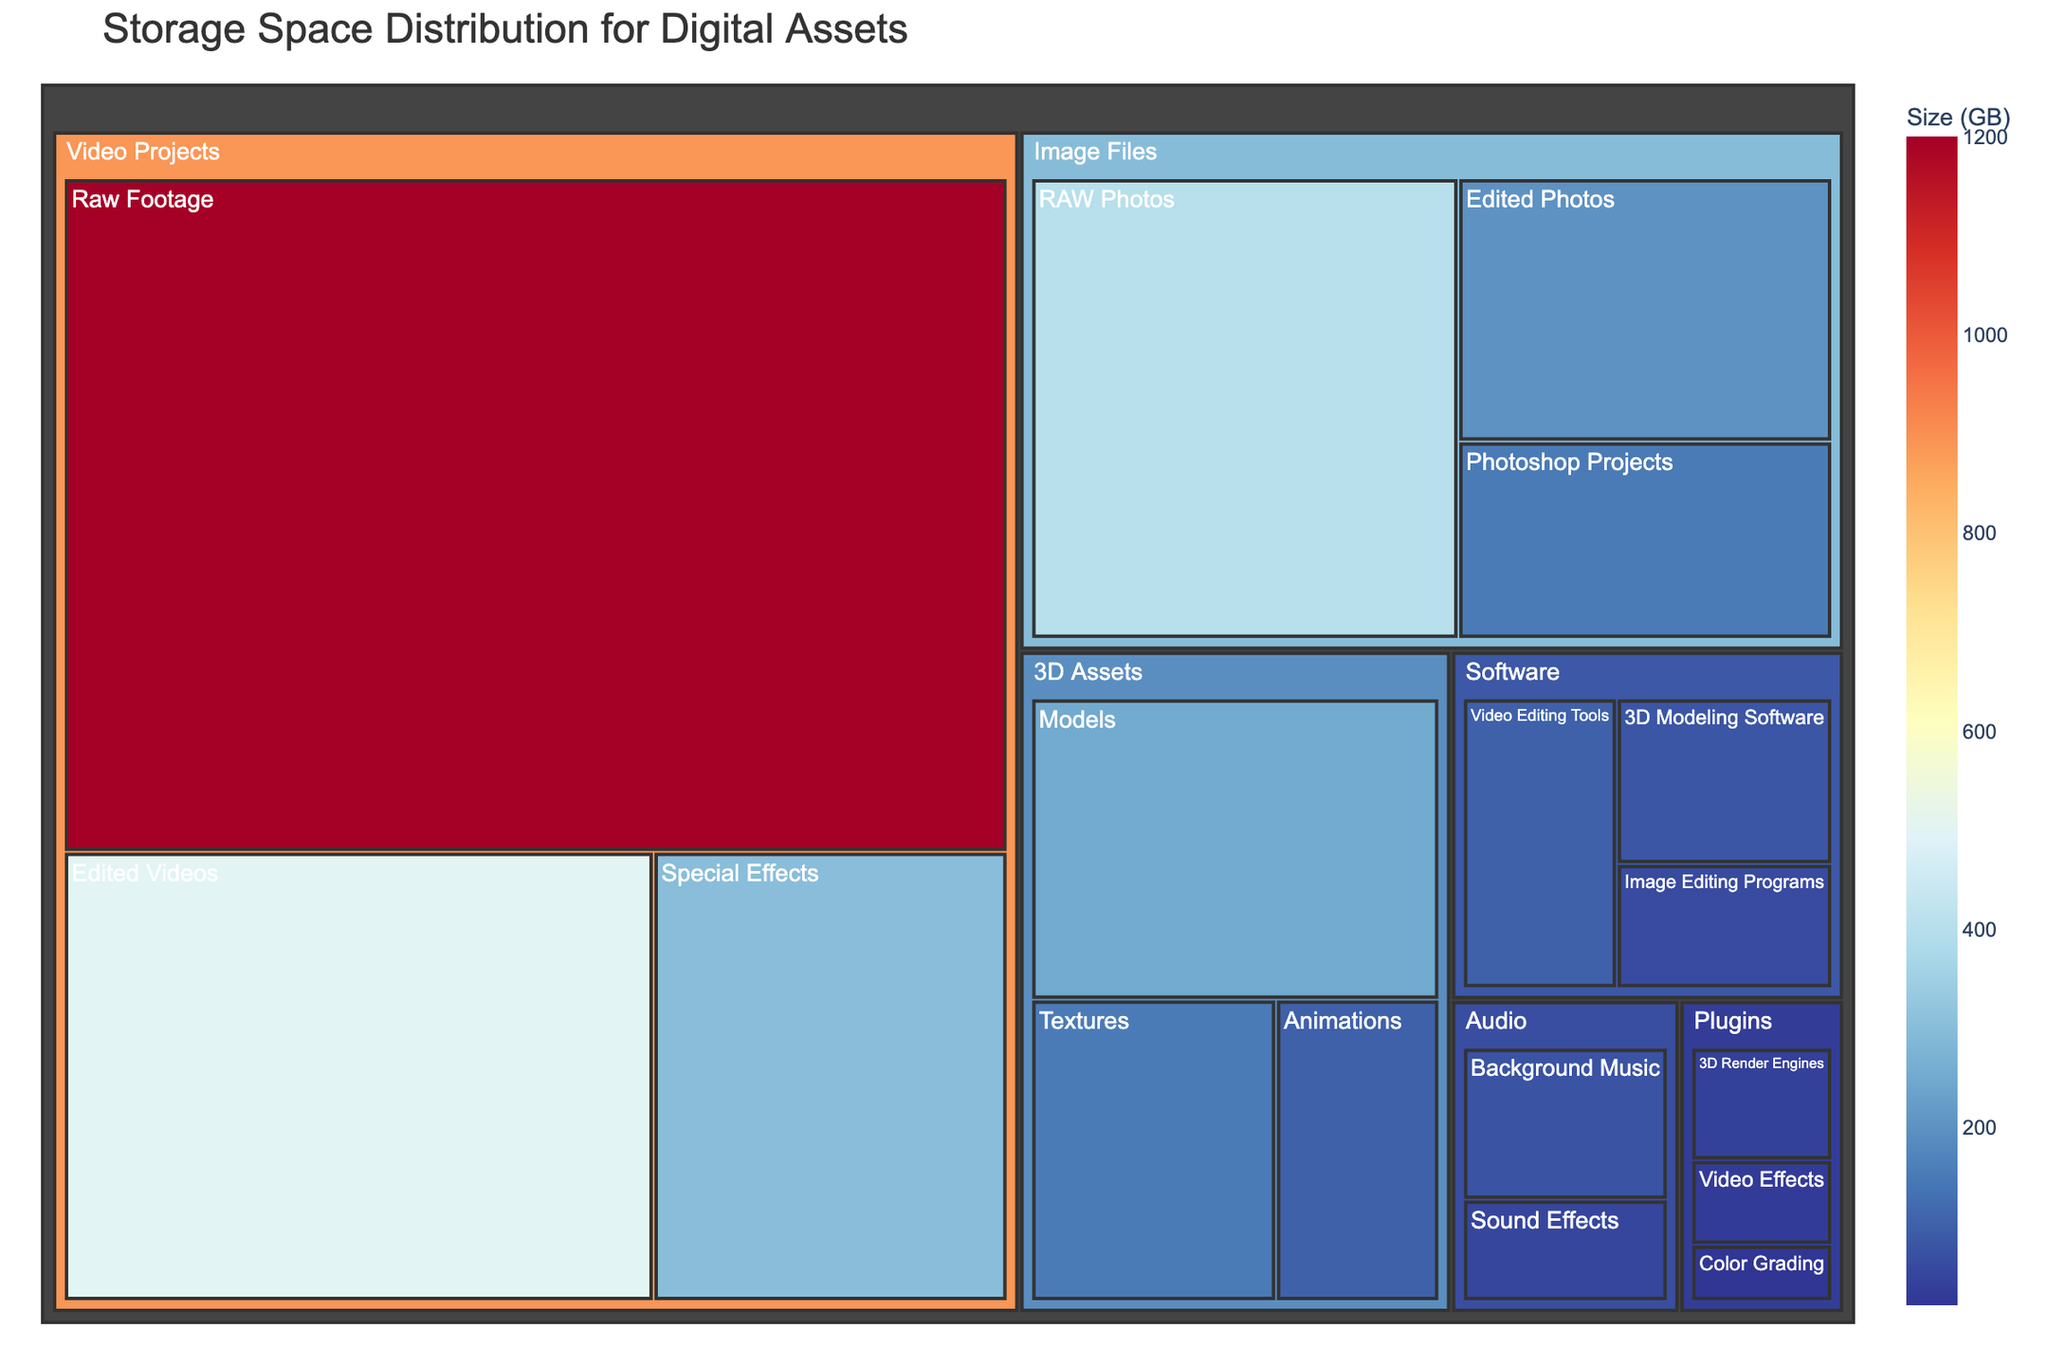How much storage space is used for Raw Footage? The Raw Footage subcategory under Video Projects has a size of 1200 GB in the figure.
Answer: 1200 GB Which subcategory in the Image Files category takes up the most storage? In the Image Files category, RAW Photos takes up the most storage with 400 GB.
Answer: RAW Photos Compare the storage space used by Background Music and Edited Videos. Background Music under Audio uses 75 GB, while Edited Videos under Video Projects uses 500 GB.
Answer: Edited Videos uses more space What's the total storage used by the 3D Assets category? 3D Assets includes Models (250 GB), Textures (150 GB), and Animations (100 GB). Adding them up: 250 + 150 + 100 = 500 GB.
Answer: 500 GB Which category has the least amount of storage space used overall? Plugins has Video Effects (30 GB), Color Grading (20 GB), and 3D Render Engines (40 GB), totaling 90 GB. Other categories use more space.
Answer: Plugins What's the combined storage size for all Video Projects subcategories? Raw Footage (1200 GB) + Edited Videos (500 GB) + Special Effects (300 GB) = 2000 GB.
Answer: 2000 GB What is the difference in storage between the largest and smallest categories? The largest category is Video Projects (1200 + 500 + 300 = 2000 GB) and the smallest is Plugins (30 + 20 + 40 = 90 GB). 2000 - 90 = 1910 GB.
Answer: 1910 GB Which has more storage: Image Editing Programs or Video Effects plugins? Image Editing Programs (60 GB) versus Video Effects plugins (30 GB).
Answer: Image Editing Programs What color scale is used in the treemap? The color scale used is a reversed RdYlBu color scale, ranging from blue to red.
Answer: Reversed RdYlBu Which subcategory in Software is the largest? In Software, Video Editing Tools is the largest subcategory with 100 GB.
Answer: Video Editing Tools 